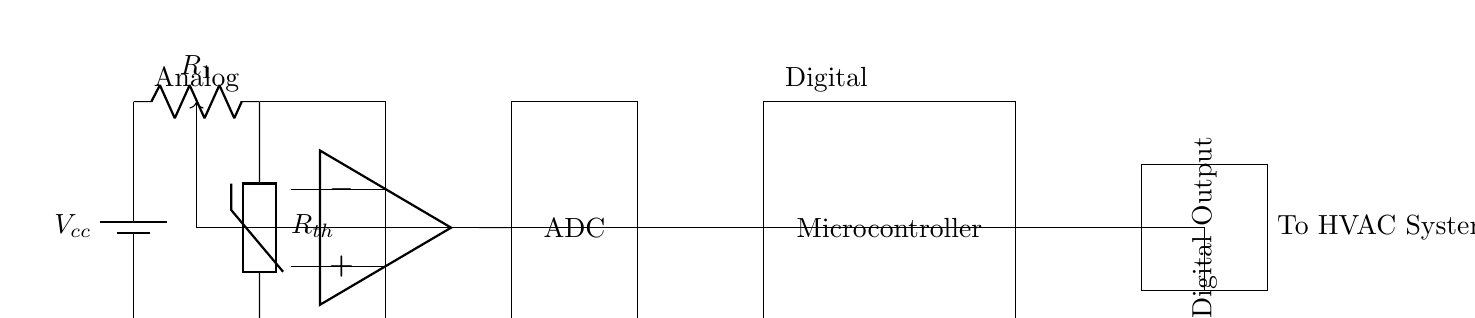What type of resistor is used in this circuit? The circuit employs a thermistor, which is a type of resistor that changes its resistance based on temperature. The diagram explicitly labels this component as Rth.
Answer: thermistor What is the function of the operational amplifier in this circuit? The operational amplifier is an active component that amplifies the voltage signal from the thermistor, providing the necessary gain to the ADC output. It is located between the thermistor and the ADC in the diagram.
Answer: amplify What does ADC stand for in this context? In this diagram, ADC stands for Analog-to-Digital Converter, which transforms the analog signal from the operational amplifier into a digital signal for processing by the microcontroller. This function is crucial for interfacing analog signals with digital systems.
Answer: Analog-to-Digital Converter What component connects the digital output to the HVAC system? The digital output is connected to the HVAC system, which receives control signals. This connection implies that the digital output directly interfaces with the heating, ventilation, and air conditioning mechanism of the smart home.
Answer: Digital Output How many main parts are in this hybrid thermostat circuit? The circuit consists of two main parts: the analog section which includes the battery, resistor, thermistor, and operational amplifier, and the digital section comprising the ADC and microcontroller. The clear division is indicated by the labels in the diagram.
Answer: two What role does the feedback loop serve in this circuit? The feedback loop informs the system about the current temperature status, allowing for continuous monitoring and adjustment of the thermostat settings based on the sensor input. The loop connects back to the analog section to maintain control and accuracy.
Answer: monitoring 